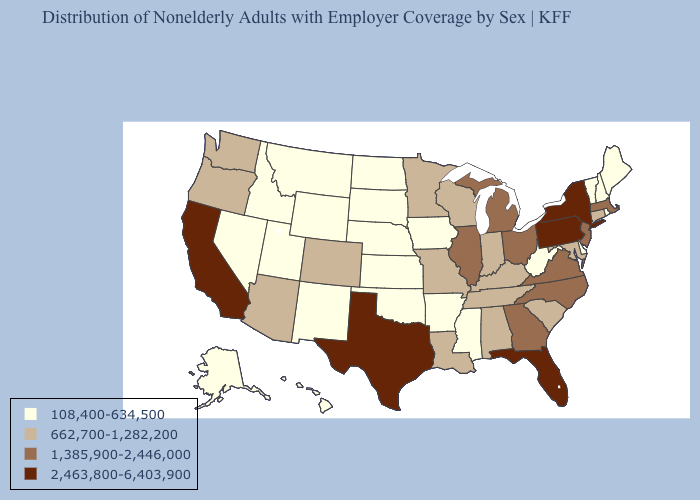Does Wyoming have a lower value than Virginia?
Short answer required. Yes. What is the value of Missouri?
Be succinct. 662,700-1,282,200. Name the states that have a value in the range 108,400-634,500?
Answer briefly. Alaska, Arkansas, Delaware, Hawaii, Idaho, Iowa, Kansas, Maine, Mississippi, Montana, Nebraska, Nevada, New Hampshire, New Mexico, North Dakota, Oklahoma, Rhode Island, South Dakota, Utah, Vermont, West Virginia, Wyoming. Does Illinois have the highest value in the USA?
Keep it brief. No. What is the value of Maryland?
Keep it brief. 662,700-1,282,200. What is the lowest value in the USA?
Keep it brief. 108,400-634,500. What is the value of Michigan?
Concise answer only. 1,385,900-2,446,000. What is the value of West Virginia?
Give a very brief answer. 108,400-634,500. Does Florida have the highest value in the South?
Concise answer only. Yes. What is the value of Kansas?
Concise answer only. 108,400-634,500. Name the states that have a value in the range 2,463,800-6,403,900?
Keep it brief. California, Florida, New York, Pennsylvania, Texas. Name the states that have a value in the range 2,463,800-6,403,900?
Write a very short answer. California, Florida, New York, Pennsylvania, Texas. Does South Carolina have the lowest value in the South?
Be succinct. No. Does the map have missing data?
Be succinct. No. 